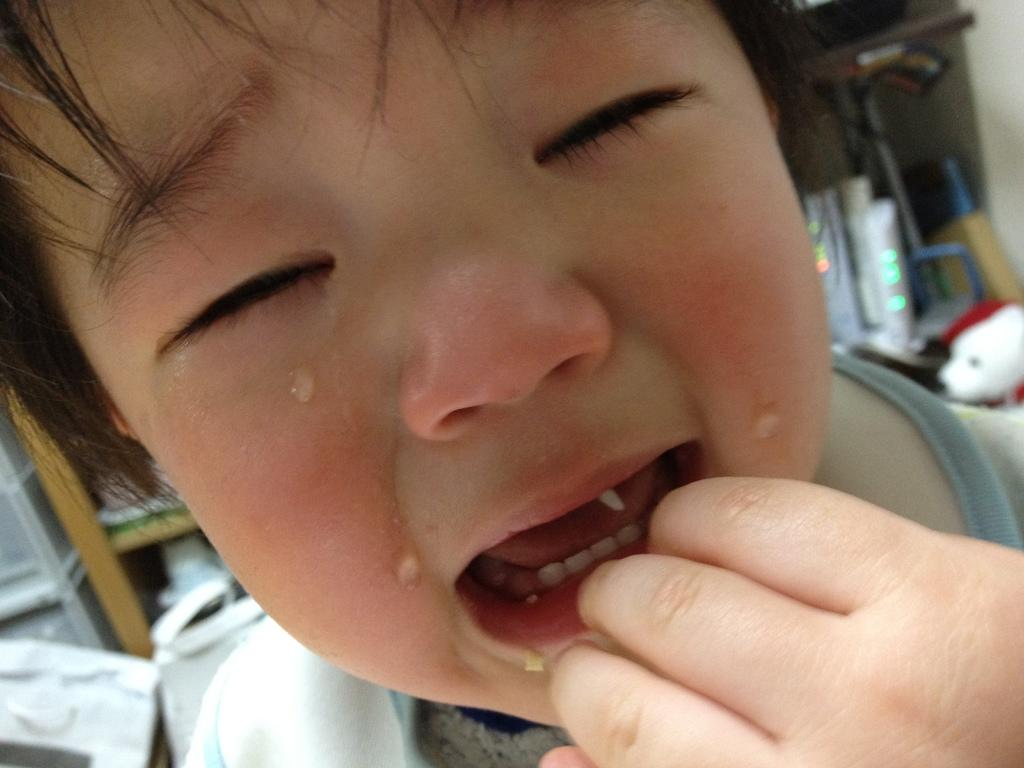What is the emotional state of the baby in the image? The baby is crying in the image. How would you describe the background of the image? The background is blurred in the image. What object can be seen in the image that might be used for storage? There is a rack in the image. What type of toy is present in the image? There is a teddy in the image. Can you describe any other objects visible in the image? There are other things visible in the image, but their specific details are not mentioned in the provided facts. How many girls are visible in the image? There are no girls present in the image; it features a crying baby and a teddy. What type of plate is being used by the baby in the image? There is no plate visible in the image. 